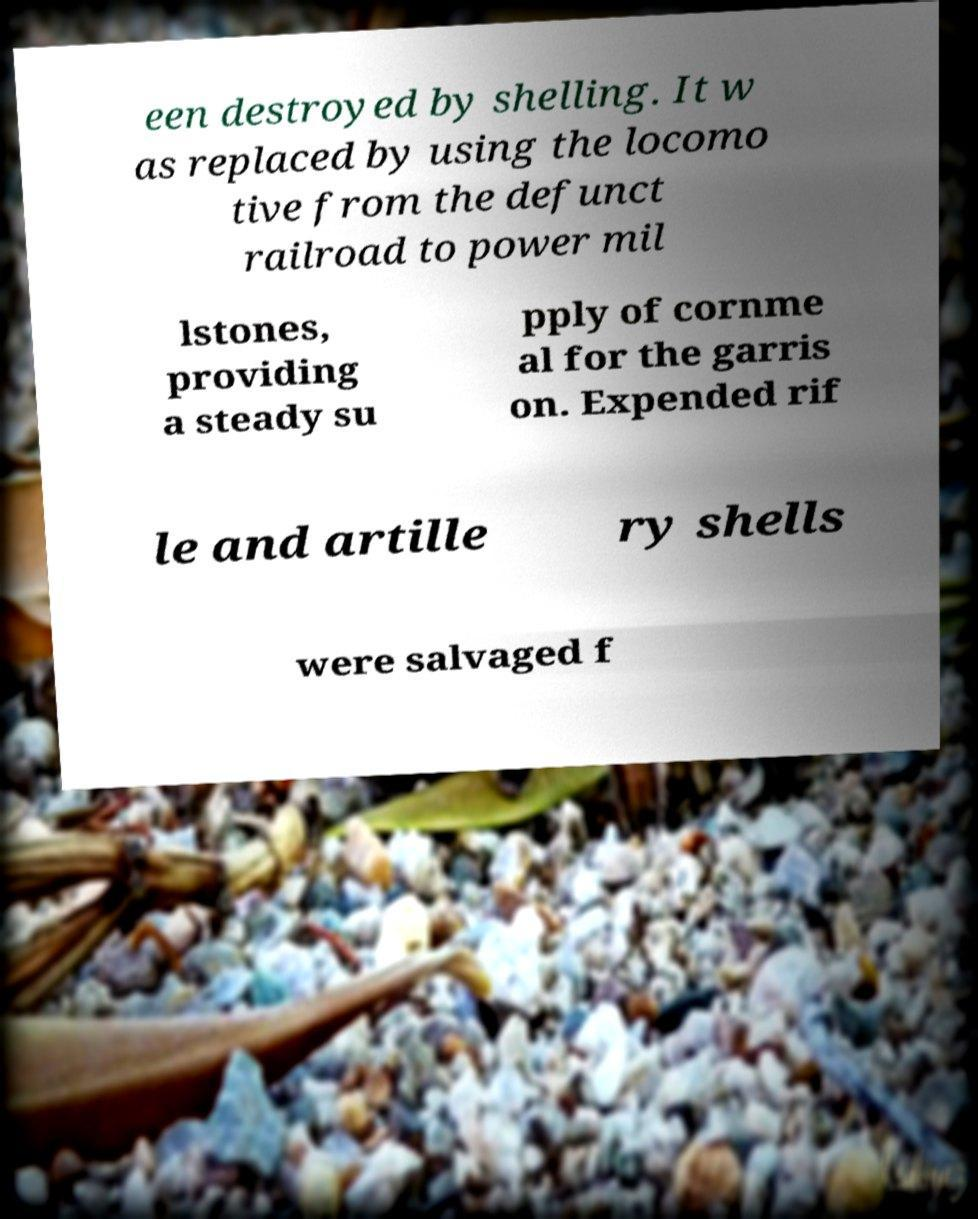What messages or text are displayed in this image? I need them in a readable, typed format. een destroyed by shelling. It w as replaced by using the locomo tive from the defunct railroad to power mil lstones, providing a steady su pply of cornme al for the garris on. Expended rif le and artille ry shells were salvaged f 